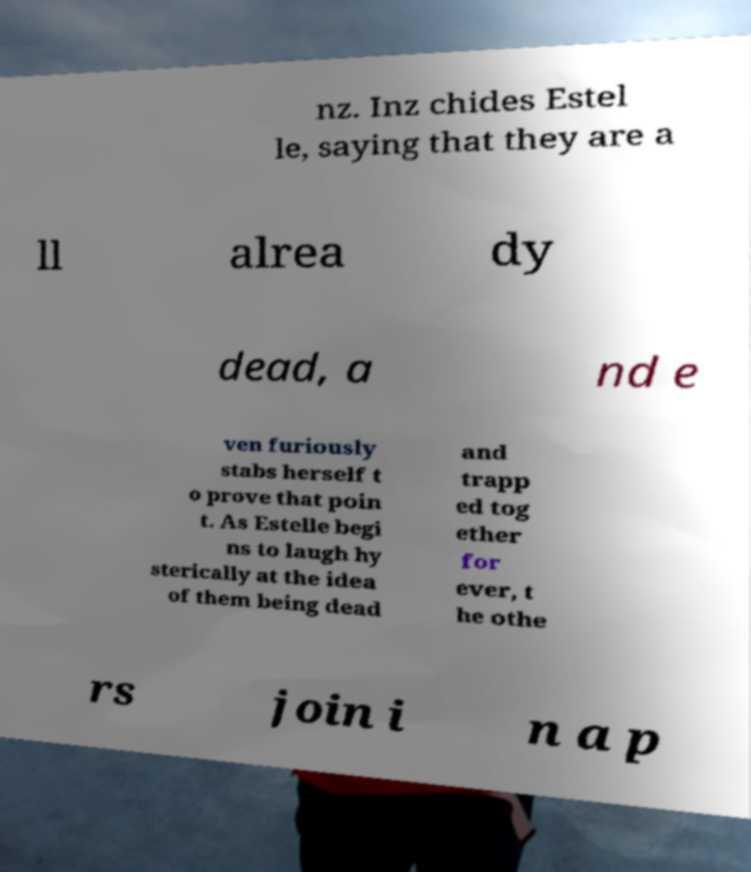For documentation purposes, I need the text within this image transcribed. Could you provide that? nz. Inz chides Estel le, saying that they are a ll alrea dy dead, a nd e ven furiously stabs herself t o prove that poin t. As Estelle begi ns to laugh hy sterically at the idea of them being dead and trapp ed tog ether for ever, t he othe rs join i n a p 